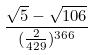<formula> <loc_0><loc_0><loc_500><loc_500>\frac { \sqrt { 5 } - \sqrt { 1 0 6 } } { ( \frac { 2 } { 4 2 9 } ) ^ { 3 6 6 } }</formula> 